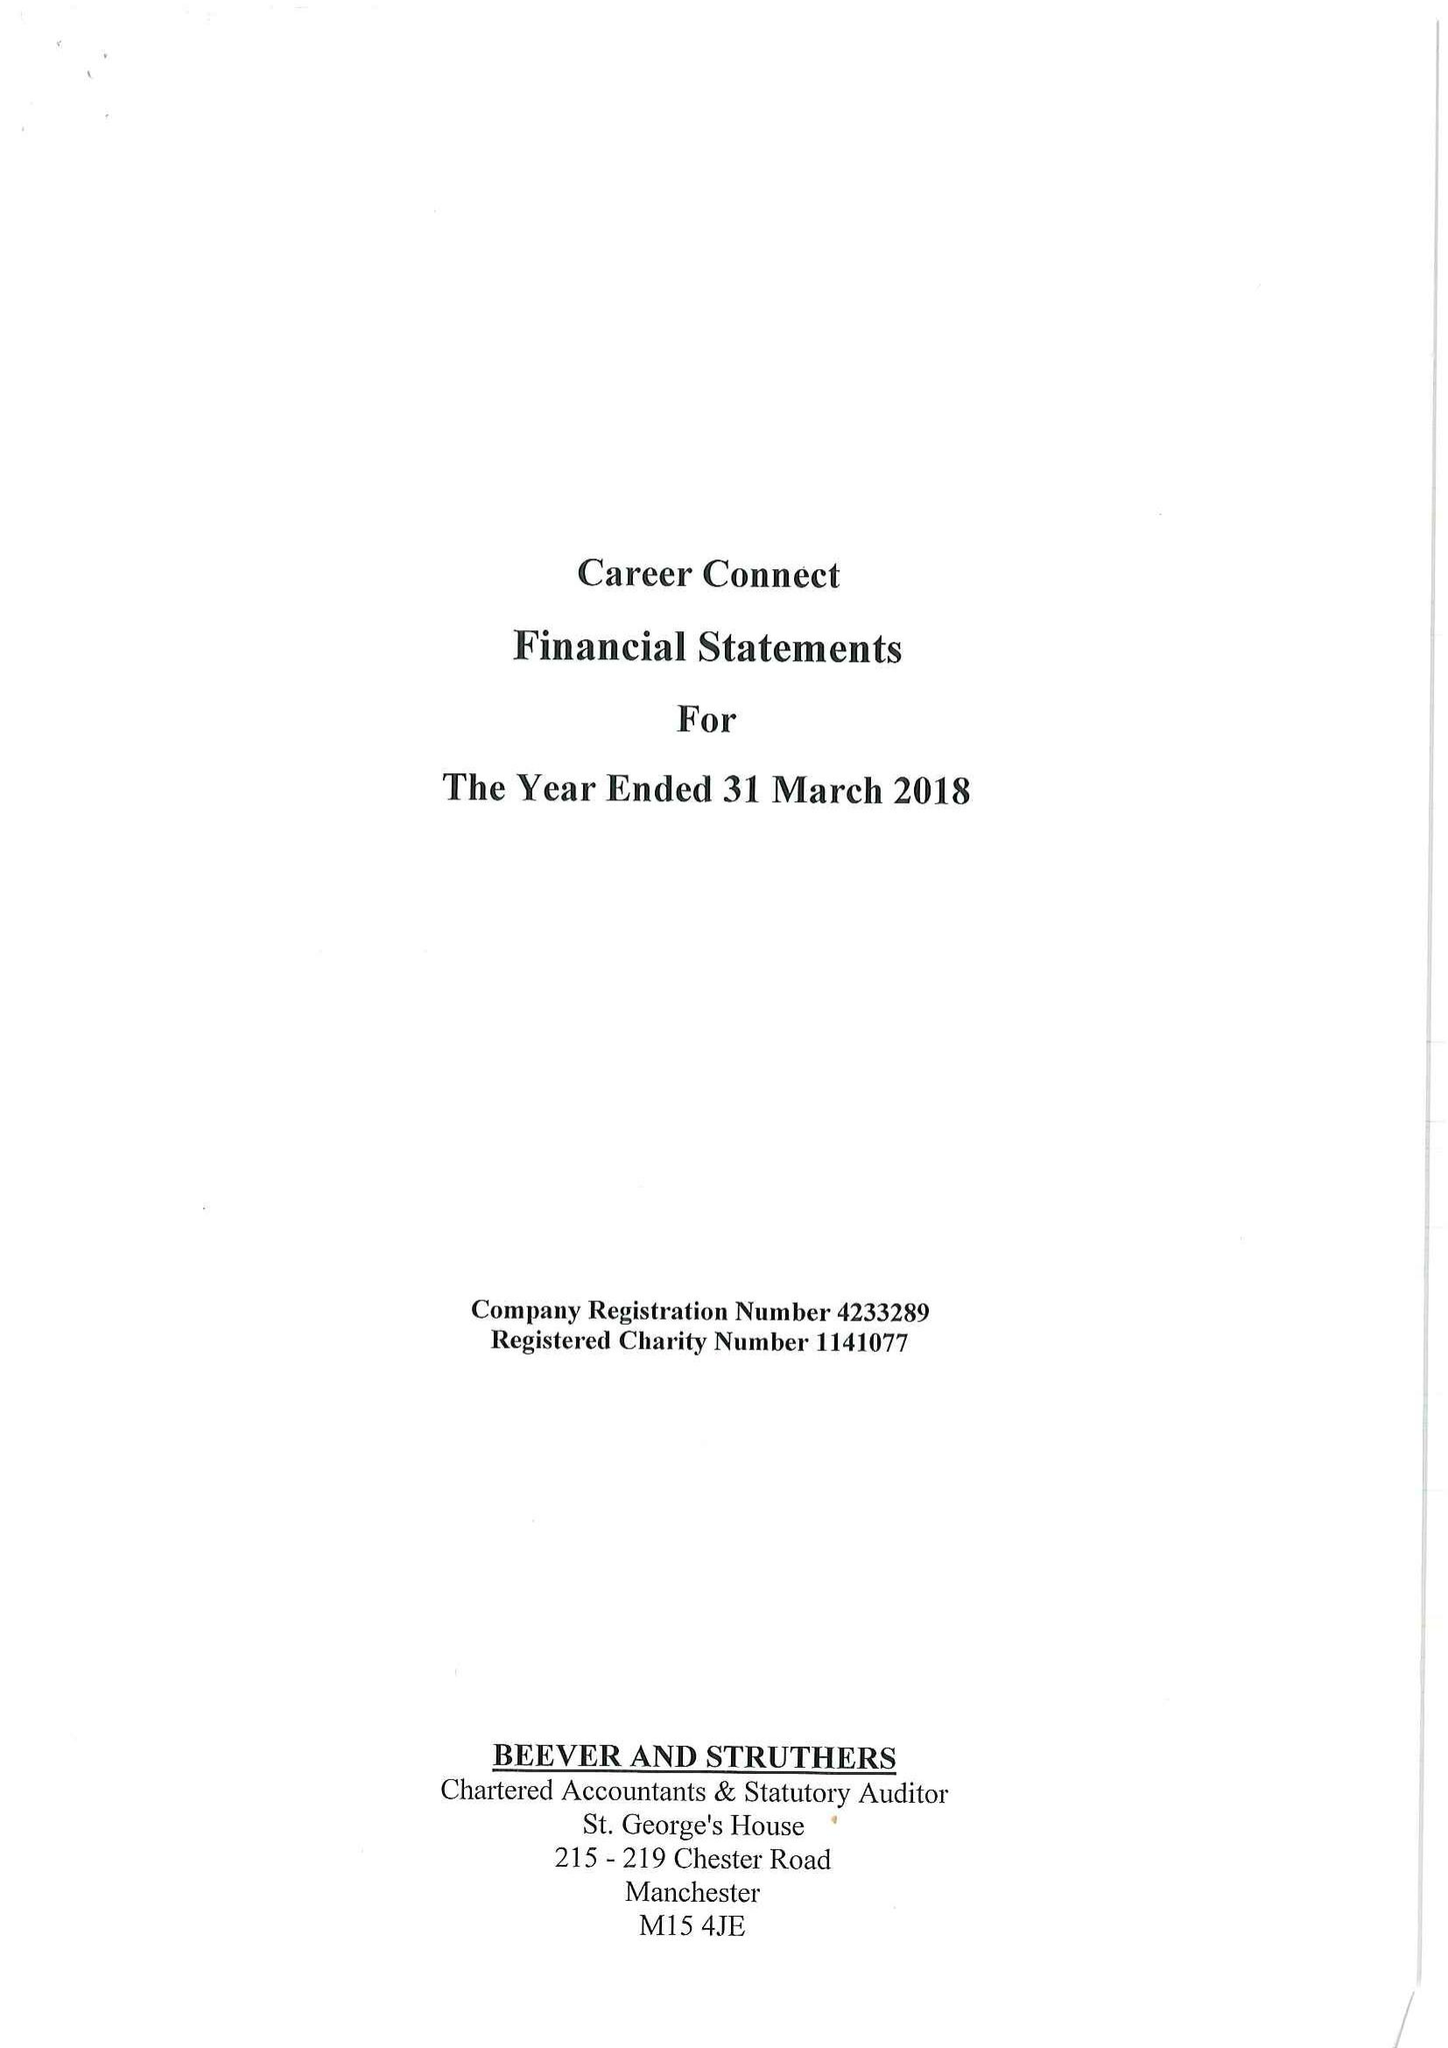What is the value for the address__street_line?
Answer the question using a single word or phrase. None 